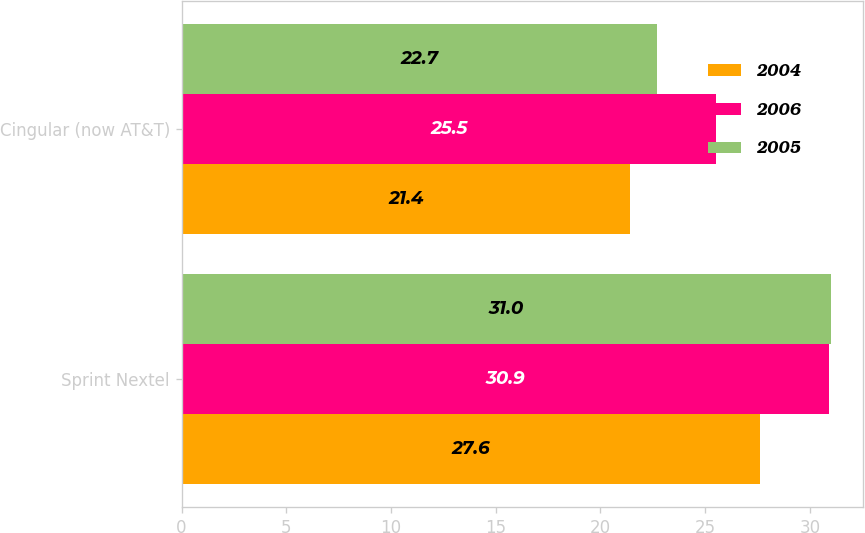Convert chart. <chart><loc_0><loc_0><loc_500><loc_500><stacked_bar_chart><ecel><fcel>Sprint Nextel<fcel>Cingular (now AT&T)<nl><fcel>2004<fcel>27.6<fcel>21.4<nl><fcel>2006<fcel>30.9<fcel>25.5<nl><fcel>2005<fcel>31<fcel>22.7<nl></chart> 